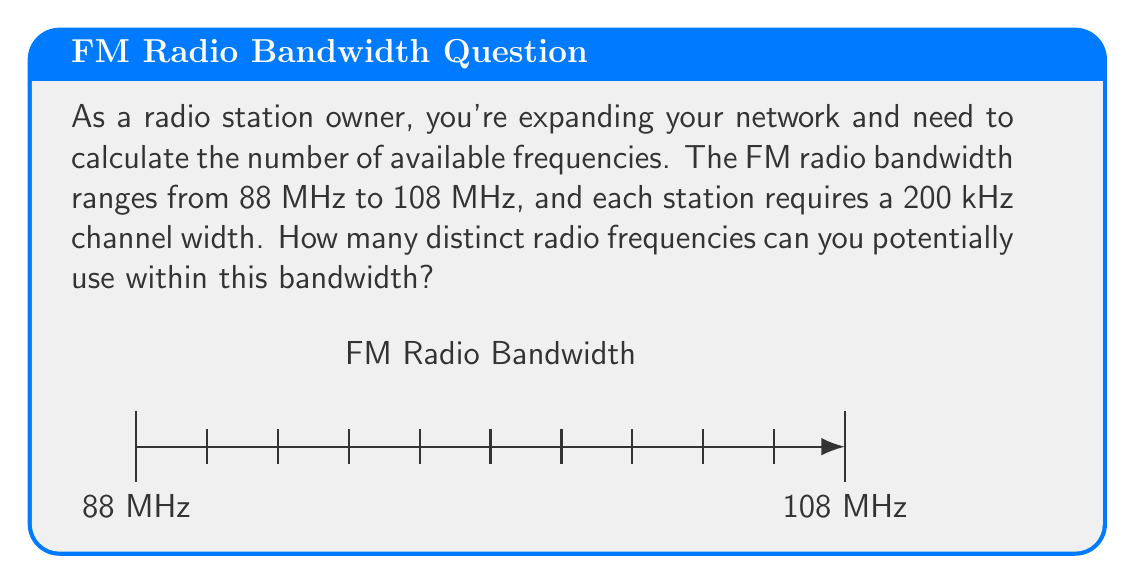Solve this math problem. Let's approach this step-by-step:

1) First, we need to calculate the total bandwidth:
   $$ \text{Total bandwidth} = 108 \text{ MHz} - 88 \text{ MHz} = 20 \text{ MHz} $$

2) Convert the total bandwidth to kHz:
   $$ 20 \text{ MHz} = 20,000 \text{ kHz} $$

3) Each station requires a 200 kHz channel width. To find the number of channels, we divide the total bandwidth by the channel width:

   $$ \text{Number of channels} = \frac{\text{Total bandwidth}}{\text{Channel width}} $$

   $$ = \frac{20,000 \text{ kHz}}{200 \text{ kHz}} = 100 $$

Therefore, there are 100 distinct radio frequencies available within the given FM radio bandwidth.

This calculation demonstrates the efficiency of radio broadcasting, allowing for a significant number of stations within a relatively narrow bandwidth - a key advantage for radio advertising campaigns over traditional print media.
Answer: 100 frequencies 